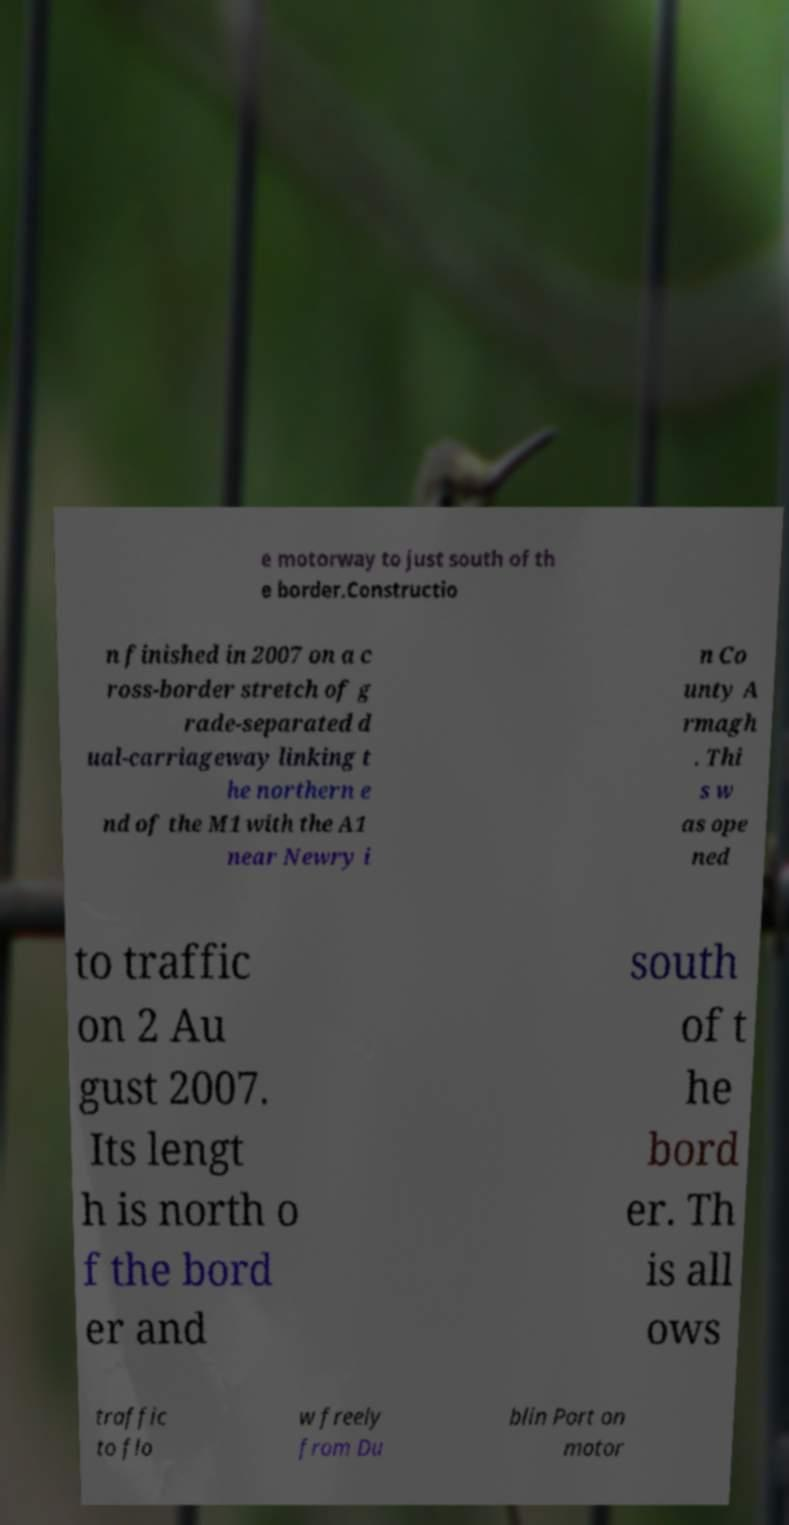What messages or text are displayed in this image? I need them in a readable, typed format. e motorway to just south of th e border.Constructio n finished in 2007 on a c ross-border stretch of g rade-separated d ual-carriageway linking t he northern e nd of the M1 with the A1 near Newry i n Co unty A rmagh . Thi s w as ope ned to traffic on 2 Au gust 2007. Its lengt h is north o f the bord er and south of t he bord er. Th is all ows traffic to flo w freely from Du blin Port on motor 